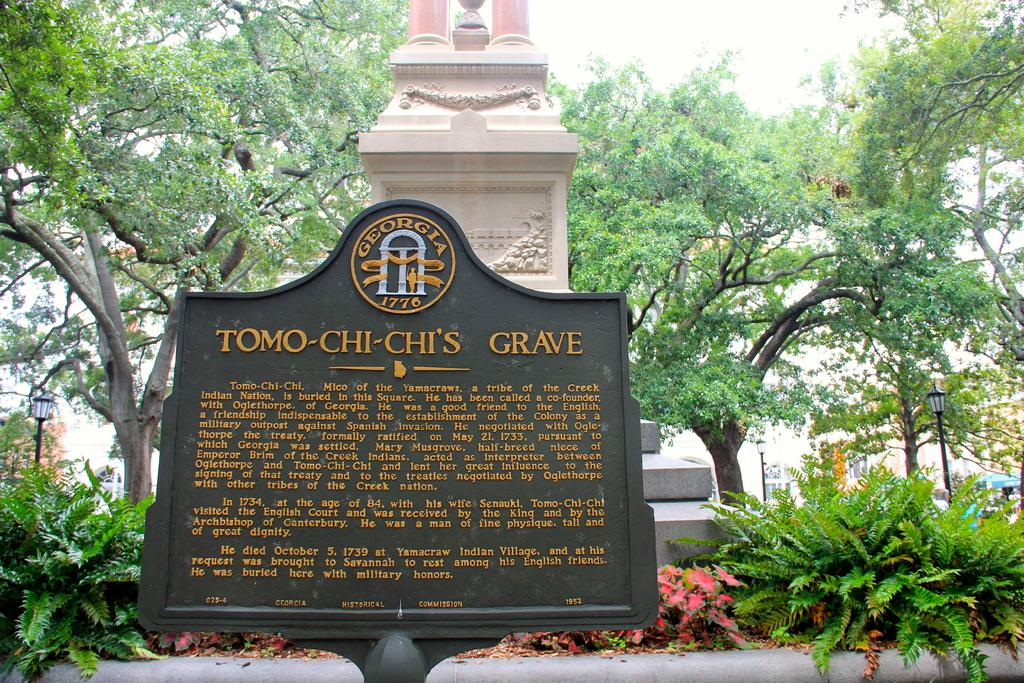What is the main subject of the image? The main subject of the image is a gravestone. What can be found near the gravestone? There is a grave in the image. What type of vegetation is present in the image? There are shrubs, trees, and possibly grass in the image. What man-made structures are visible in the image? There are street poles, street lights, and buildings in the image. What part of the natural environment is visible in the image? The sky is visible in the image. What language is being spoken by the quilt in the image? There is no quilt present in the image, and therefore no language can be attributed to it. 